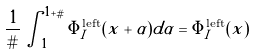Convert formula to latex. <formula><loc_0><loc_0><loc_500><loc_500>\frac { 1 } { \# } \int _ { 1 } ^ { 1 + \# } \Phi _ { I } ^ { \text {left} } ( x + \alpha ) d \alpha = \Phi _ { I } ^ { \text {left} } ( x )</formula> 